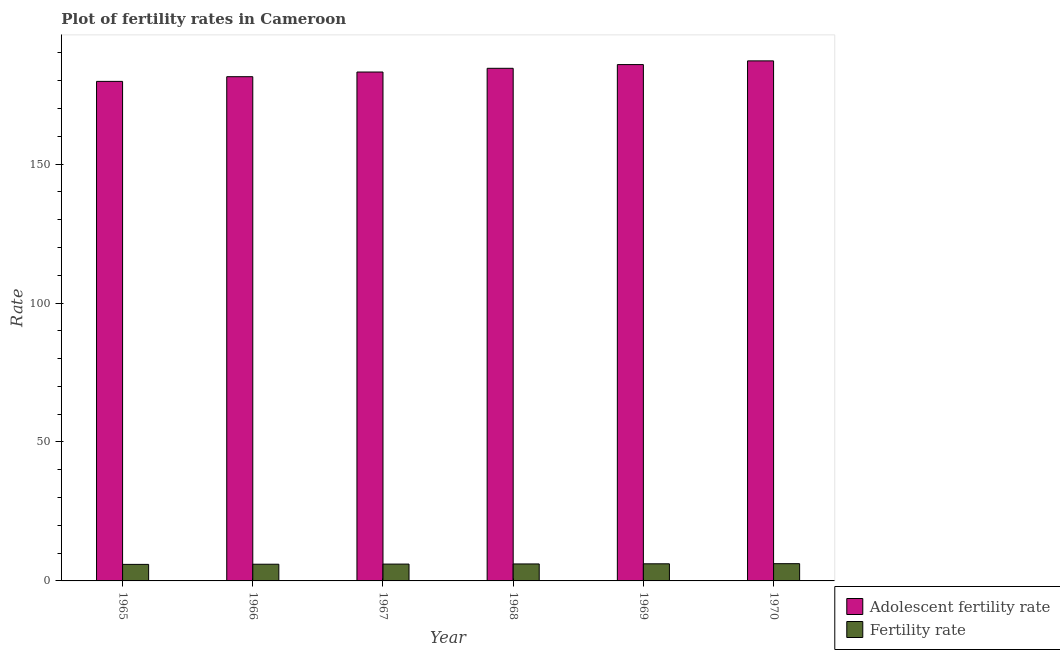How many groups of bars are there?
Offer a terse response. 6. Are the number of bars on each tick of the X-axis equal?
Provide a succinct answer. Yes. How many bars are there on the 5th tick from the right?
Keep it short and to the point. 2. What is the label of the 1st group of bars from the left?
Keep it short and to the point. 1965. What is the adolescent fertility rate in 1967?
Offer a very short reply. 183.12. Across all years, what is the maximum fertility rate?
Your answer should be very brief. 6.21. Across all years, what is the minimum fertility rate?
Ensure brevity in your answer.  5.95. In which year was the adolescent fertility rate maximum?
Your answer should be compact. 1970. In which year was the adolescent fertility rate minimum?
Ensure brevity in your answer.  1965. What is the total fertility rate in the graph?
Your response must be concise. 36.49. What is the difference between the adolescent fertility rate in 1965 and that in 1969?
Your response must be concise. -6.04. What is the difference between the adolescent fertility rate in 1969 and the fertility rate in 1965?
Your response must be concise. 6.04. What is the average adolescent fertility rate per year?
Ensure brevity in your answer.  183.62. What is the ratio of the fertility rate in 1965 to that in 1970?
Keep it short and to the point. 0.96. Is the fertility rate in 1968 less than that in 1970?
Your response must be concise. Yes. What is the difference between the highest and the second highest adolescent fertility rate?
Provide a succinct answer. 1.34. What is the difference between the highest and the lowest adolescent fertility rate?
Offer a very short reply. 7.38. Is the sum of the adolescent fertility rate in 1966 and 1968 greater than the maximum fertility rate across all years?
Your answer should be very brief. Yes. What does the 1st bar from the left in 1967 represents?
Your response must be concise. Adolescent fertility rate. What does the 1st bar from the right in 1970 represents?
Offer a terse response. Fertility rate. How many years are there in the graph?
Your answer should be very brief. 6. Does the graph contain grids?
Provide a succinct answer. No. Where does the legend appear in the graph?
Ensure brevity in your answer.  Bottom right. What is the title of the graph?
Make the answer very short. Plot of fertility rates in Cameroon. What is the label or title of the X-axis?
Provide a succinct answer. Year. What is the label or title of the Y-axis?
Offer a terse response. Rate. What is the Rate in Adolescent fertility rate in 1965?
Offer a terse response. 179.75. What is the Rate of Fertility rate in 1965?
Give a very brief answer. 5.95. What is the Rate of Adolescent fertility rate in 1966?
Make the answer very short. 181.44. What is the Rate in Fertility rate in 1966?
Ensure brevity in your answer.  6. What is the Rate in Adolescent fertility rate in 1967?
Make the answer very short. 183.12. What is the Rate in Fertility rate in 1967?
Keep it short and to the point. 6.06. What is the Rate in Adolescent fertility rate in 1968?
Provide a short and direct response. 184.46. What is the Rate of Fertility rate in 1968?
Keep it short and to the point. 6.11. What is the Rate in Adolescent fertility rate in 1969?
Ensure brevity in your answer.  185.79. What is the Rate of Fertility rate in 1969?
Provide a short and direct response. 6.16. What is the Rate in Adolescent fertility rate in 1970?
Provide a succinct answer. 187.13. What is the Rate in Fertility rate in 1970?
Ensure brevity in your answer.  6.21. Across all years, what is the maximum Rate in Adolescent fertility rate?
Your answer should be very brief. 187.13. Across all years, what is the maximum Rate in Fertility rate?
Make the answer very short. 6.21. Across all years, what is the minimum Rate of Adolescent fertility rate?
Give a very brief answer. 179.75. Across all years, what is the minimum Rate of Fertility rate?
Keep it short and to the point. 5.95. What is the total Rate of Adolescent fertility rate in the graph?
Offer a terse response. 1101.69. What is the total Rate in Fertility rate in the graph?
Provide a short and direct response. 36.49. What is the difference between the Rate in Adolescent fertility rate in 1965 and that in 1966?
Your answer should be very brief. -1.69. What is the difference between the Rate in Fertility rate in 1965 and that in 1966?
Your answer should be very brief. -0.06. What is the difference between the Rate of Adolescent fertility rate in 1965 and that in 1967?
Offer a terse response. -3.37. What is the difference between the Rate of Fertility rate in 1965 and that in 1967?
Provide a succinct answer. -0.11. What is the difference between the Rate of Adolescent fertility rate in 1965 and that in 1968?
Keep it short and to the point. -4.71. What is the difference between the Rate in Fertility rate in 1965 and that in 1968?
Provide a succinct answer. -0.16. What is the difference between the Rate in Adolescent fertility rate in 1965 and that in 1969?
Offer a very short reply. -6.04. What is the difference between the Rate in Fertility rate in 1965 and that in 1969?
Ensure brevity in your answer.  -0.21. What is the difference between the Rate of Adolescent fertility rate in 1965 and that in 1970?
Ensure brevity in your answer.  -7.38. What is the difference between the Rate of Fertility rate in 1965 and that in 1970?
Provide a succinct answer. -0.26. What is the difference between the Rate of Adolescent fertility rate in 1966 and that in 1967?
Provide a succinct answer. -1.69. What is the difference between the Rate of Fertility rate in 1966 and that in 1967?
Offer a terse response. -0.05. What is the difference between the Rate in Adolescent fertility rate in 1966 and that in 1968?
Make the answer very short. -3.02. What is the difference between the Rate of Fertility rate in 1966 and that in 1968?
Your answer should be very brief. -0.1. What is the difference between the Rate in Adolescent fertility rate in 1966 and that in 1969?
Offer a terse response. -4.36. What is the difference between the Rate of Fertility rate in 1966 and that in 1969?
Provide a succinct answer. -0.15. What is the difference between the Rate of Adolescent fertility rate in 1966 and that in 1970?
Your answer should be compact. -5.69. What is the difference between the Rate in Adolescent fertility rate in 1967 and that in 1968?
Keep it short and to the point. -1.34. What is the difference between the Rate in Fertility rate in 1967 and that in 1968?
Your answer should be compact. -0.05. What is the difference between the Rate of Adolescent fertility rate in 1967 and that in 1969?
Offer a terse response. -2.67. What is the difference between the Rate in Fertility rate in 1967 and that in 1969?
Keep it short and to the point. -0.1. What is the difference between the Rate of Adolescent fertility rate in 1967 and that in 1970?
Your answer should be compact. -4.01. What is the difference between the Rate in Fertility rate in 1967 and that in 1970?
Ensure brevity in your answer.  -0.15. What is the difference between the Rate of Adolescent fertility rate in 1968 and that in 1969?
Ensure brevity in your answer.  -1.34. What is the difference between the Rate in Fertility rate in 1968 and that in 1969?
Offer a terse response. -0.05. What is the difference between the Rate of Adolescent fertility rate in 1968 and that in 1970?
Provide a short and direct response. -2.67. What is the difference between the Rate in Fertility rate in 1968 and that in 1970?
Make the answer very short. -0.1. What is the difference between the Rate of Adolescent fertility rate in 1969 and that in 1970?
Provide a succinct answer. -1.34. What is the difference between the Rate in Fertility rate in 1969 and that in 1970?
Ensure brevity in your answer.  -0.05. What is the difference between the Rate of Adolescent fertility rate in 1965 and the Rate of Fertility rate in 1966?
Give a very brief answer. 173.75. What is the difference between the Rate in Adolescent fertility rate in 1965 and the Rate in Fertility rate in 1967?
Your answer should be compact. 173.69. What is the difference between the Rate of Adolescent fertility rate in 1965 and the Rate of Fertility rate in 1968?
Provide a succinct answer. 173.64. What is the difference between the Rate in Adolescent fertility rate in 1965 and the Rate in Fertility rate in 1969?
Provide a short and direct response. 173.59. What is the difference between the Rate in Adolescent fertility rate in 1965 and the Rate in Fertility rate in 1970?
Your response must be concise. 173.55. What is the difference between the Rate of Adolescent fertility rate in 1966 and the Rate of Fertility rate in 1967?
Ensure brevity in your answer.  175.38. What is the difference between the Rate of Adolescent fertility rate in 1966 and the Rate of Fertility rate in 1968?
Ensure brevity in your answer.  175.33. What is the difference between the Rate in Adolescent fertility rate in 1966 and the Rate in Fertility rate in 1969?
Keep it short and to the point. 175.28. What is the difference between the Rate in Adolescent fertility rate in 1966 and the Rate in Fertility rate in 1970?
Give a very brief answer. 175.23. What is the difference between the Rate of Adolescent fertility rate in 1967 and the Rate of Fertility rate in 1968?
Provide a short and direct response. 177.01. What is the difference between the Rate of Adolescent fertility rate in 1967 and the Rate of Fertility rate in 1969?
Offer a very short reply. 176.96. What is the difference between the Rate of Adolescent fertility rate in 1967 and the Rate of Fertility rate in 1970?
Keep it short and to the point. 176.92. What is the difference between the Rate of Adolescent fertility rate in 1968 and the Rate of Fertility rate in 1969?
Ensure brevity in your answer.  178.3. What is the difference between the Rate of Adolescent fertility rate in 1968 and the Rate of Fertility rate in 1970?
Offer a terse response. 178.25. What is the difference between the Rate of Adolescent fertility rate in 1969 and the Rate of Fertility rate in 1970?
Give a very brief answer. 179.59. What is the average Rate of Adolescent fertility rate per year?
Your answer should be very brief. 183.62. What is the average Rate of Fertility rate per year?
Your answer should be very brief. 6.08. In the year 1965, what is the difference between the Rate of Adolescent fertility rate and Rate of Fertility rate?
Make the answer very short. 173.8. In the year 1966, what is the difference between the Rate in Adolescent fertility rate and Rate in Fertility rate?
Offer a terse response. 175.43. In the year 1967, what is the difference between the Rate of Adolescent fertility rate and Rate of Fertility rate?
Keep it short and to the point. 177.06. In the year 1968, what is the difference between the Rate of Adolescent fertility rate and Rate of Fertility rate?
Offer a terse response. 178.35. In the year 1969, what is the difference between the Rate in Adolescent fertility rate and Rate in Fertility rate?
Offer a very short reply. 179.64. In the year 1970, what is the difference between the Rate in Adolescent fertility rate and Rate in Fertility rate?
Keep it short and to the point. 180.93. What is the ratio of the Rate of Adolescent fertility rate in 1965 to that in 1966?
Keep it short and to the point. 0.99. What is the ratio of the Rate in Fertility rate in 1965 to that in 1966?
Your answer should be very brief. 0.99. What is the ratio of the Rate in Adolescent fertility rate in 1965 to that in 1967?
Your answer should be very brief. 0.98. What is the ratio of the Rate in Fertility rate in 1965 to that in 1967?
Provide a short and direct response. 0.98. What is the ratio of the Rate of Adolescent fertility rate in 1965 to that in 1968?
Your response must be concise. 0.97. What is the ratio of the Rate of Fertility rate in 1965 to that in 1968?
Provide a succinct answer. 0.97. What is the ratio of the Rate of Adolescent fertility rate in 1965 to that in 1969?
Offer a very short reply. 0.97. What is the ratio of the Rate of Fertility rate in 1965 to that in 1969?
Offer a very short reply. 0.97. What is the ratio of the Rate in Adolescent fertility rate in 1965 to that in 1970?
Your answer should be compact. 0.96. What is the ratio of the Rate in Fertility rate in 1965 to that in 1970?
Provide a succinct answer. 0.96. What is the ratio of the Rate of Adolescent fertility rate in 1966 to that in 1967?
Ensure brevity in your answer.  0.99. What is the ratio of the Rate in Adolescent fertility rate in 1966 to that in 1968?
Your answer should be very brief. 0.98. What is the ratio of the Rate of Fertility rate in 1966 to that in 1968?
Your response must be concise. 0.98. What is the ratio of the Rate in Adolescent fertility rate in 1966 to that in 1969?
Ensure brevity in your answer.  0.98. What is the ratio of the Rate of Adolescent fertility rate in 1966 to that in 1970?
Provide a short and direct response. 0.97. What is the ratio of the Rate of Fertility rate in 1966 to that in 1970?
Provide a succinct answer. 0.97. What is the ratio of the Rate of Fertility rate in 1967 to that in 1968?
Keep it short and to the point. 0.99. What is the ratio of the Rate in Adolescent fertility rate in 1967 to that in 1969?
Your response must be concise. 0.99. What is the ratio of the Rate in Fertility rate in 1967 to that in 1969?
Keep it short and to the point. 0.98. What is the ratio of the Rate of Adolescent fertility rate in 1967 to that in 1970?
Offer a terse response. 0.98. What is the ratio of the Rate of Fertility rate in 1967 to that in 1970?
Ensure brevity in your answer.  0.98. What is the ratio of the Rate in Adolescent fertility rate in 1968 to that in 1969?
Offer a very short reply. 0.99. What is the ratio of the Rate of Fertility rate in 1968 to that in 1969?
Your answer should be very brief. 0.99. What is the ratio of the Rate of Adolescent fertility rate in 1968 to that in 1970?
Your answer should be compact. 0.99. What is the ratio of the Rate in Fertility rate in 1968 to that in 1970?
Keep it short and to the point. 0.98. What is the difference between the highest and the second highest Rate of Adolescent fertility rate?
Give a very brief answer. 1.34. What is the difference between the highest and the second highest Rate in Fertility rate?
Offer a very short reply. 0.05. What is the difference between the highest and the lowest Rate in Adolescent fertility rate?
Offer a very short reply. 7.38. What is the difference between the highest and the lowest Rate of Fertility rate?
Keep it short and to the point. 0.26. 